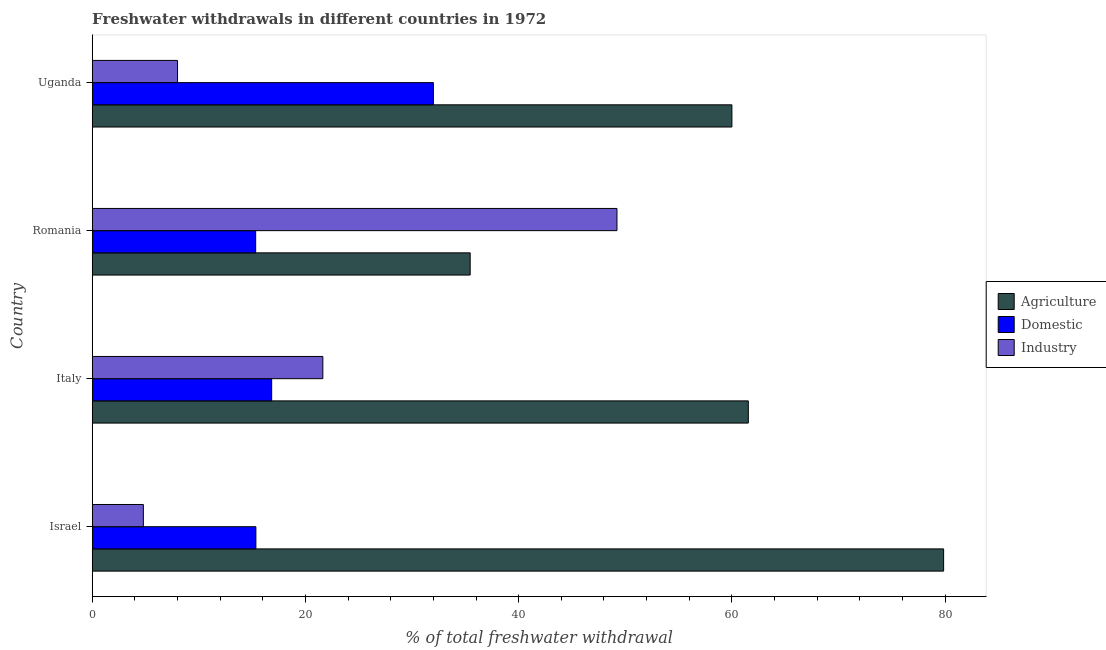How many groups of bars are there?
Your answer should be compact. 4. Are the number of bars on each tick of the Y-axis equal?
Keep it short and to the point. Yes. What is the label of the 2nd group of bars from the top?
Provide a succinct answer. Romania. What is the percentage of freshwater withdrawal for industry in Israel?
Your response must be concise. 4.79. Across all countries, what is the maximum percentage of freshwater withdrawal for industry?
Keep it short and to the point. 49.22. Across all countries, what is the minimum percentage of freshwater withdrawal for industry?
Ensure brevity in your answer.  4.79. In which country was the percentage of freshwater withdrawal for domestic purposes maximum?
Ensure brevity in your answer.  Uganda. In which country was the percentage of freshwater withdrawal for agriculture minimum?
Ensure brevity in your answer.  Romania. What is the total percentage of freshwater withdrawal for agriculture in the graph?
Your answer should be compact. 236.85. What is the difference between the percentage of freshwater withdrawal for industry in Israel and that in Uganda?
Provide a short and direct response. -3.21. What is the difference between the percentage of freshwater withdrawal for industry in Romania and the percentage of freshwater withdrawal for domestic purposes in Israel?
Your answer should be compact. 33.87. What is the average percentage of freshwater withdrawal for domestic purposes per country?
Your response must be concise. 19.88. What is the difference between the percentage of freshwater withdrawal for agriculture and percentage of freshwater withdrawal for industry in Italy?
Offer a terse response. 39.91. What is the ratio of the percentage of freshwater withdrawal for domestic purposes in Israel to that in Italy?
Keep it short and to the point. 0.91. What is the difference between the highest and the second highest percentage of freshwater withdrawal for domestic purposes?
Offer a very short reply. 15.17. What is the difference between the highest and the lowest percentage of freshwater withdrawal for industry?
Keep it short and to the point. 44.42. Is the sum of the percentage of freshwater withdrawal for agriculture in Israel and Romania greater than the maximum percentage of freshwater withdrawal for industry across all countries?
Ensure brevity in your answer.  Yes. What does the 1st bar from the top in Romania represents?
Keep it short and to the point. Industry. What does the 3rd bar from the bottom in Israel represents?
Give a very brief answer. Industry. How many bars are there?
Ensure brevity in your answer.  12. How many countries are there in the graph?
Provide a short and direct response. 4. Does the graph contain any zero values?
Make the answer very short. No. How are the legend labels stacked?
Keep it short and to the point. Vertical. What is the title of the graph?
Ensure brevity in your answer.  Freshwater withdrawals in different countries in 1972. Does "Taxes on income" appear as one of the legend labels in the graph?
Provide a short and direct response. No. What is the label or title of the X-axis?
Offer a very short reply. % of total freshwater withdrawal. What is the % of total freshwater withdrawal in Agriculture in Israel?
Make the answer very short. 79.86. What is the % of total freshwater withdrawal of Domestic in Israel?
Provide a short and direct response. 15.35. What is the % of total freshwater withdrawal of Industry in Israel?
Make the answer very short. 4.79. What is the % of total freshwater withdrawal of Agriculture in Italy?
Offer a very short reply. 61.54. What is the % of total freshwater withdrawal of Domestic in Italy?
Offer a very short reply. 16.83. What is the % of total freshwater withdrawal in Industry in Italy?
Provide a succinct answer. 21.63. What is the % of total freshwater withdrawal of Agriculture in Romania?
Your response must be concise. 35.45. What is the % of total freshwater withdrawal of Domestic in Romania?
Ensure brevity in your answer.  15.33. What is the % of total freshwater withdrawal of Industry in Romania?
Your response must be concise. 49.22. Across all countries, what is the maximum % of total freshwater withdrawal of Agriculture?
Your response must be concise. 79.86. Across all countries, what is the maximum % of total freshwater withdrawal in Industry?
Offer a terse response. 49.22. Across all countries, what is the minimum % of total freshwater withdrawal of Agriculture?
Ensure brevity in your answer.  35.45. Across all countries, what is the minimum % of total freshwater withdrawal in Domestic?
Offer a very short reply. 15.33. Across all countries, what is the minimum % of total freshwater withdrawal of Industry?
Ensure brevity in your answer.  4.79. What is the total % of total freshwater withdrawal in Agriculture in the graph?
Provide a succinct answer. 236.85. What is the total % of total freshwater withdrawal of Domestic in the graph?
Keep it short and to the point. 79.51. What is the total % of total freshwater withdrawal in Industry in the graph?
Offer a terse response. 83.64. What is the difference between the % of total freshwater withdrawal in Agriculture in Israel and that in Italy?
Keep it short and to the point. 18.32. What is the difference between the % of total freshwater withdrawal of Domestic in Israel and that in Italy?
Your response must be concise. -1.48. What is the difference between the % of total freshwater withdrawal in Industry in Israel and that in Italy?
Your response must be concise. -16.84. What is the difference between the % of total freshwater withdrawal in Agriculture in Israel and that in Romania?
Give a very brief answer. 44.41. What is the difference between the % of total freshwater withdrawal in Domestic in Israel and that in Romania?
Provide a short and direct response. 0.02. What is the difference between the % of total freshwater withdrawal in Industry in Israel and that in Romania?
Make the answer very short. -44.42. What is the difference between the % of total freshwater withdrawal in Agriculture in Israel and that in Uganda?
Your response must be concise. 19.86. What is the difference between the % of total freshwater withdrawal in Domestic in Israel and that in Uganda?
Your answer should be very brief. -16.65. What is the difference between the % of total freshwater withdrawal in Industry in Israel and that in Uganda?
Make the answer very short. -3.21. What is the difference between the % of total freshwater withdrawal of Agriculture in Italy and that in Romania?
Ensure brevity in your answer.  26.09. What is the difference between the % of total freshwater withdrawal in Industry in Italy and that in Romania?
Provide a short and direct response. -27.59. What is the difference between the % of total freshwater withdrawal of Agriculture in Italy and that in Uganda?
Provide a short and direct response. 1.54. What is the difference between the % of total freshwater withdrawal of Domestic in Italy and that in Uganda?
Your answer should be compact. -15.17. What is the difference between the % of total freshwater withdrawal in Industry in Italy and that in Uganda?
Provide a succinct answer. 13.63. What is the difference between the % of total freshwater withdrawal in Agriculture in Romania and that in Uganda?
Provide a short and direct response. -24.55. What is the difference between the % of total freshwater withdrawal in Domestic in Romania and that in Uganda?
Your response must be concise. -16.67. What is the difference between the % of total freshwater withdrawal in Industry in Romania and that in Uganda?
Give a very brief answer. 41.22. What is the difference between the % of total freshwater withdrawal of Agriculture in Israel and the % of total freshwater withdrawal of Domestic in Italy?
Your response must be concise. 63.03. What is the difference between the % of total freshwater withdrawal of Agriculture in Israel and the % of total freshwater withdrawal of Industry in Italy?
Provide a short and direct response. 58.23. What is the difference between the % of total freshwater withdrawal in Domestic in Israel and the % of total freshwater withdrawal in Industry in Italy?
Provide a succinct answer. -6.28. What is the difference between the % of total freshwater withdrawal of Agriculture in Israel and the % of total freshwater withdrawal of Domestic in Romania?
Make the answer very short. 64.53. What is the difference between the % of total freshwater withdrawal of Agriculture in Israel and the % of total freshwater withdrawal of Industry in Romania?
Give a very brief answer. 30.64. What is the difference between the % of total freshwater withdrawal of Domestic in Israel and the % of total freshwater withdrawal of Industry in Romania?
Your response must be concise. -33.87. What is the difference between the % of total freshwater withdrawal in Agriculture in Israel and the % of total freshwater withdrawal in Domestic in Uganda?
Your answer should be very brief. 47.86. What is the difference between the % of total freshwater withdrawal of Agriculture in Israel and the % of total freshwater withdrawal of Industry in Uganda?
Your answer should be very brief. 71.86. What is the difference between the % of total freshwater withdrawal in Domestic in Israel and the % of total freshwater withdrawal in Industry in Uganda?
Give a very brief answer. 7.35. What is the difference between the % of total freshwater withdrawal in Agriculture in Italy and the % of total freshwater withdrawal in Domestic in Romania?
Your answer should be very brief. 46.21. What is the difference between the % of total freshwater withdrawal of Agriculture in Italy and the % of total freshwater withdrawal of Industry in Romania?
Your answer should be compact. 12.32. What is the difference between the % of total freshwater withdrawal in Domestic in Italy and the % of total freshwater withdrawal in Industry in Romania?
Keep it short and to the point. -32.39. What is the difference between the % of total freshwater withdrawal of Agriculture in Italy and the % of total freshwater withdrawal of Domestic in Uganda?
Provide a short and direct response. 29.54. What is the difference between the % of total freshwater withdrawal in Agriculture in Italy and the % of total freshwater withdrawal in Industry in Uganda?
Ensure brevity in your answer.  53.54. What is the difference between the % of total freshwater withdrawal in Domestic in Italy and the % of total freshwater withdrawal in Industry in Uganda?
Provide a short and direct response. 8.83. What is the difference between the % of total freshwater withdrawal of Agriculture in Romania and the % of total freshwater withdrawal of Domestic in Uganda?
Provide a short and direct response. 3.45. What is the difference between the % of total freshwater withdrawal of Agriculture in Romania and the % of total freshwater withdrawal of Industry in Uganda?
Ensure brevity in your answer.  27.45. What is the difference between the % of total freshwater withdrawal of Domestic in Romania and the % of total freshwater withdrawal of Industry in Uganda?
Offer a terse response. 7.33. What is the average % of total freshwater withdrawal in Agriculture per country?
Provide a short and direct response. 59.21. What is the average % of total freshwater withdrawal in Domestic per country?
Give a very brief answer. 19.88. What is the average % of total freshwater withdrawal of Industry per country?
Your answer should be compact. 20.91. What is the difference between the % of total freshwater withdrawal in Agriculture and % of total freshwater withdrawal in Domestic in Israel?
Offer a very short reply. 64.51. What is the difference between the % of total freshwater withdrawal of Agriculture and % of total freshwater withdrawal of Industry in Israel?
Provide a short and direct response. 75.06. What is the difference between the % of total freshwater withdrawal of Domestic and % of total freshwater withdrawal of Industry in Israel?
Your answer should be very brief. 10.55. What is the difference between the % of total freshwater withdrawal of Agriculture and % of total freshwater withdrawal of Domestic in Italy?
Give a very brief answer. 44.71. What is the difference between the % of total freshwater withdrawal in Agriculture and % of total freshwater withdrawal in Industry in Italy?
Provide a short and direct response. 39.91. What is the difference between the % of total freshwater withdrawal in Agriculture and % of total freshwater withdrawal in Domestic in Romania?
Give a very brief answer. 20.12. What is the difference between the % of total freshwater withdrawal of Agriculture and % of total freshwater withdrawal of Industry in Romania?
Keep it short and to the point. -13.77. What is the difference between the % of total freshwater withdrawal in Domestic and % of total freshwater withdrawal in Industry in Romania?
Offer a terse response. -33.89. What is the difference between the % of total freshwater withdrawal of Domestic and % of total freshwater withdrawal of Industry in Uganda?
Your response must be concise. 24. What is the ratio of the % of total freshwater withdrawal in Agriculture in Israel to that in Italy?
Your answer should be compact. 1.3. What is the ratio of the % of total freshwater withdrawal of Domestic in Israel to that in Italy?
Make the answer very short. 0.91. What is the ratio of the % of total freshwater withdrawal of Industry in Israel to that in Italy?
Ensure brevity in your answer.  0.22. What is the ratio of the % of total freshwater withdrawal in Agriculture in Israel to that in Romania?
Provide a short and direct response. 2.25. What is the ratio of the % of total freshwater withdrawal of Industry in Israel to that in Romania?
Provide a short and direct response. 0.1. What is the ratio of the % of total freshwater withdrawal of Agriculture in Israel to that in Uganda?
Ensure brevity in your answer.  1.33. What is the ratio of the % of total freshwater withdrawal of Domestic in Israel to that in Uganda?
Offer a terse response. 0.48. What is the ratio of the % of total freshwater withdrawal of Industry in Israel to that in Uganda?
Make the answer very short. 0.6. What is the ratio of the % of total freshwater withdrawal of Agriculture in Italy to that in Romania?
Ensure brevity in your answer.  1.74. What is the ratio of the % of total freshwater withdrawal in Domestic in Italy to that in Romania?
Offer a very short reply. 1.1. What is the ratio of the % of total freshwater withdrawal in Industry in Italy to that in Romania?
Keep it short and to the point. 0.44. What is the ratio of the % of total freshwater withdrawal in Agriculture in Italy to that in Uganda?
Provide a succinct answer. 1.03. What is the ratio of the % of total freshwater withdrawal in Domestic in Italy to that in Uganda?
Offer a very short reply. 0.53. What is the ratio of the % of total freshwater withdrawal of Industry in Italy to that in Uganda?
Offer a very short reply. 2.7. What is the ratio of the % of total freshwater withdrawal in Agriculture in Romania to that in Uganda?
Keep it short and to the point. 0.59. What is the ratio of the % of total freshwater withdrawal in Domestic in Romania to that in Uganda?
Your answer should be very brief. 0.48. What is the ratio of the % of total freshwater withdrawal of Industry in Romania to that in Uganda?
Your answer should be compact. 6.15. What is the difference between the highest and the second highest % of total freshwater withdrawal in Agriculture?
Your answer should be very brief. 18.32. What is the difference between the highest and the second highest % of total freshwater withdrawal in Domestic?
Provide a short and direct response. 15.17. What is the difference between the highest and the second highest % of total freshwater withdrawal in Industry?
Offer a terse response. 27.59. What is the difference between the highest and the lowest % of total freshwater withdrawal of Agriculture?
Offer a very short reply. 44.41. What is the difference between the highest and the lowest % of total freshwater withdrawal in Domestic?
Offer a very short reply. 16.67. What is the difference between the highest and the lowest % of total freshwater withdrawal in Industry?
Offer a very short reply. 44.42. 